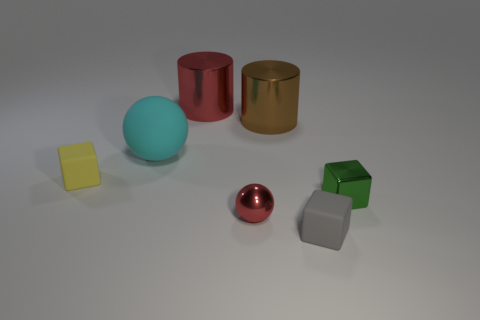Subtract all tiny matte blocks. How many blocks are left? 1 Subtract all gray cubes. How many cubes are left? 2 Subtract all cubes. How many objects are left? 4 Subtract 1 cubes. How many cubes are left? 2 Add 1 blue rubber cylinders. How many objects exist? 8 Subtract all green spheres. Subtract all red cylinders. How many spheres are left? 2 Subtract all big yellow spheres. Subtract all cubes. How many objects are left? 4 Add 6 blocks. How many blocks are left? 9 Add 3 brown shiny things. How many brown shiny things exist? 4 Subtract 0 brown cubes. How many objects are left? 7 